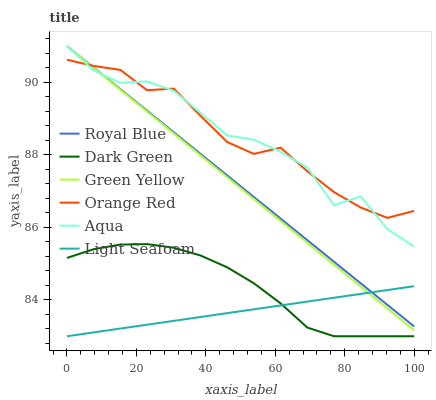Does Light Seafoam have the minimum area under the curve?
Answer yes or no. Yes. Does Orange Red have the maximum area under the curve?
Answer yes or no. Yes. Does Aqua have the minimum area under the curve?
Answer yes or no. No. Does Aqua have the maximum area under the curve?
Answer yes or no. No. Is Green Yellow the smoothest?
Answer yes or no. Yes. Is Aqua the roughest?
Answer yes or no. Yes. Is Royal Blue the smoothest?
Answer yes or no. No. Is Royal Blue the roughest?
Answer yes or no. No. Does Light Seafoam have the lowest value?
Answer yes or no. Yes. Does Aqua have the lowest value?
Answer yes or no. No. Does Green Yellow have the highest value?
Answer yes or no. Yes. Does Orange Red have the highest value?
Answer yes or no. No. Is Dark Green less than Green Yellow?
Answer yes or no. Yes. Is Orange Red greater than Dark Green?
Answer yes or no. Yes. Does Aqua intersect Green Yellow?
Answer yes or no. Yes. Is Aqua less than Green Yellow?
Answer yes or no. No. Is Aqua greater than Green Yellow?
Answer yes or no. No. Does Dark Green intersect Green Yellow?
Answer yes or no. No. 